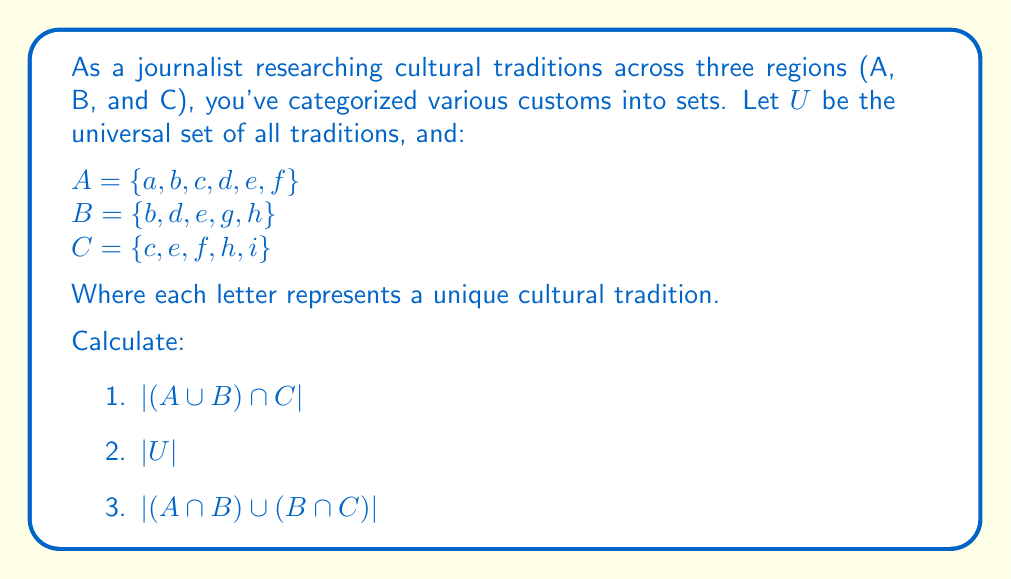Can you answer this question? Let's approach this step-by-step:

1) To find $|(A \cup B) \cap C|$:
   First, we need to find $A \cup B$:
   $A \cup B = \{a, b, c, d, e, f, g, h\}$
   
   Now, we intersect this with C:
   $(A \cup B) \cap C = \{c, e, f, h\}$
   
   Therefore, $|(A \cup B) \cap C| = 4$

2) To find $|U|$, we need to count all unique elements:
   $U = \{a, b, c, d, e, f, g, h, i\}$
   $|U| = 9$

3) To find $|(A \cap B) \cup (B \cap C)|$:
   First, we find $A \cap B$ and $B \cap C$:
   $A \cap B = \{b, d, e\}$
   $B \cap C = \{e, h\}$
   
   Now, we unite these:
   $(A \cap B) \cup (B \cap C) = \{b, d, e, h\}$
   
   Therefore, $|(A \cap B) \cup (B \cap C)| = 4$
Answer: 1) $|(A \cup B) \cap C| = 4$
2) $|U| = 9$
3) $|(A \cap B) \cup (B \cap C)| = 4$ 